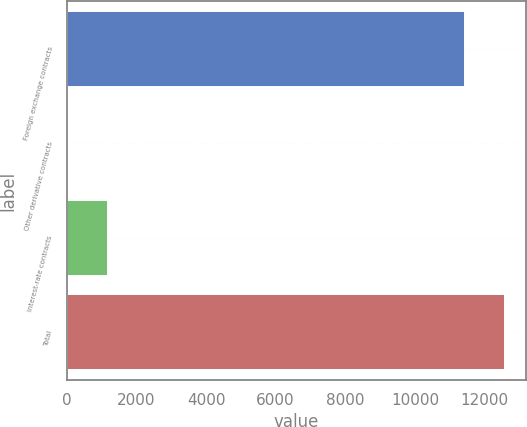Convert chart. <chart><loc_0><loc_0><loc_500><loc_500><bar_chart><fcel>Foreign exchange contracts<fcel>Other derivative contracts<fcel>Interest-rate contracts<fcel>Total<nl><fcel>11428<fcel>23<fcel>1168.7<fcel>12573.7<nl></chart> 